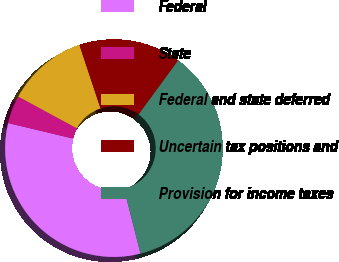Convert chart. <chart><loc_0><loc_0><loc_500><loc_500><pie_chart><fcel>Federal<fcel>State<fcel>Federal and state deferred<fcel>Uncertain tax positions and<fcel>Provision for income taxes<nl><fcel>32.68%<fcel>4.17%<fcel>11.99%<fcel>15.17%<fcel>35.98%<nl></chart> 